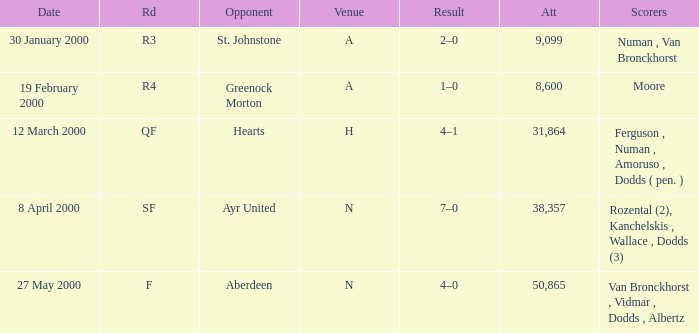What venue was on 27 May 2000? N. 